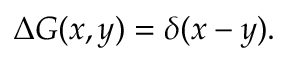<formula> <loc_0><loc_0><loc_500><loc_500>\Delta G ( x , y ) = \delta ( x - y ) .</formula> 